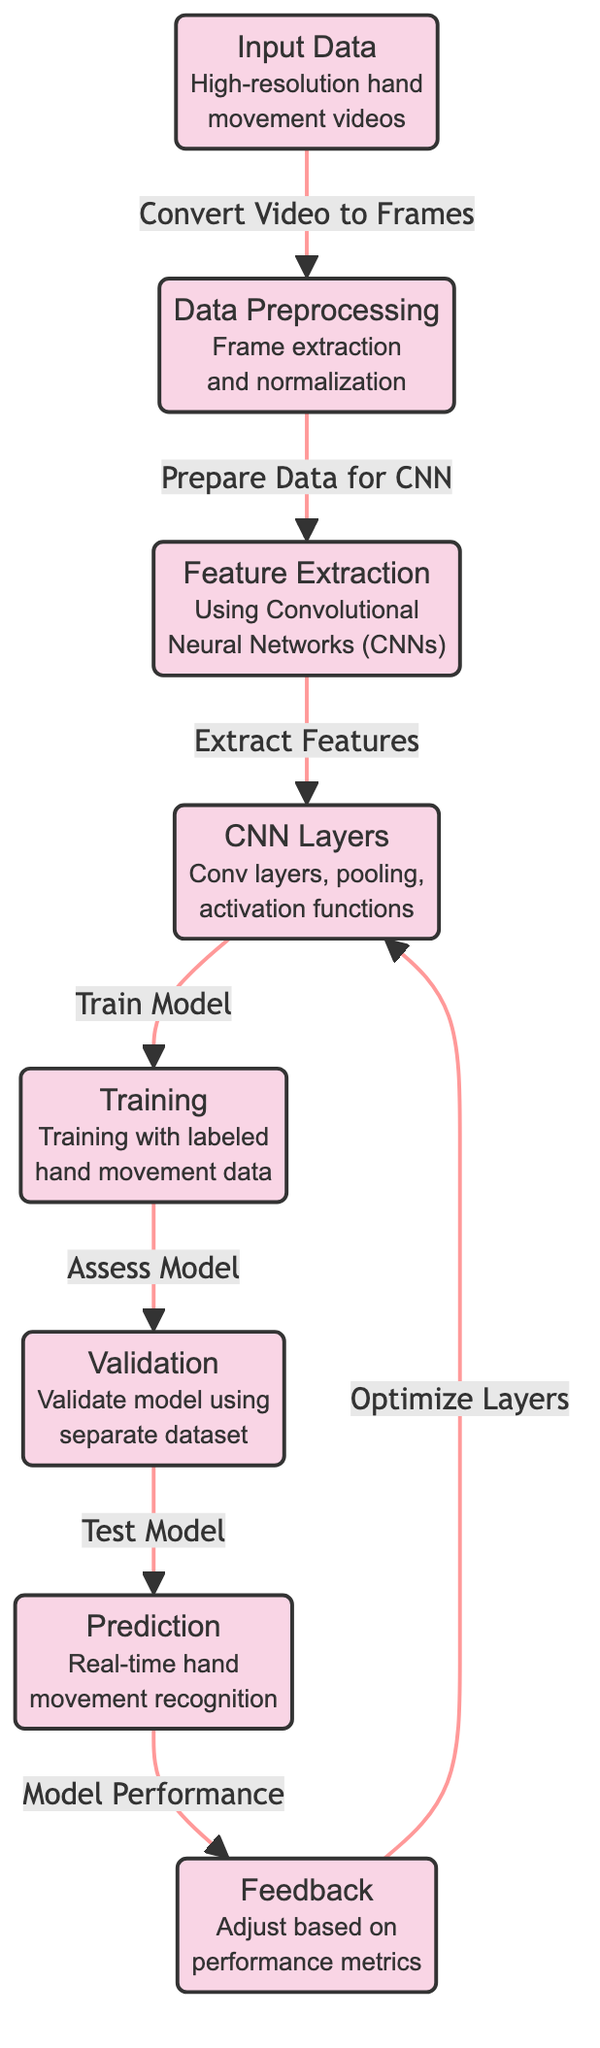What is the first step in the process? The first step in the diagram is "Input Data," which involves high-resolution hand movement videos. This is the starting point before any processing occurs.
Answer: Input Data How many nodes are there in the diagram? By counting the distinct boxes or nodes in the diagram, we find that there are a total of eight nodes. Each node represents a specific stage in the machine learning process.
Answer: Eight What type of data is used for training? The type of data used for training is labeled hand movement data. This indicates that the model learns from examples that have already been classified.
Answer: Labeled hand movement data What is the role of the feedback loop in the diagram? The feedback loop is meant to adjust the model based on performance metrics, indicating that continuous optimization of the CNN layers is necessary for improving accuracy. It shows the iterative nature of training.
Answer: Adjust based on performance metrics What is the output of the validation step? The output of the validation step is the model's prediction. This step assesses how well the model performs on a separate dataset that was not used during training.
Answer: Prediction 